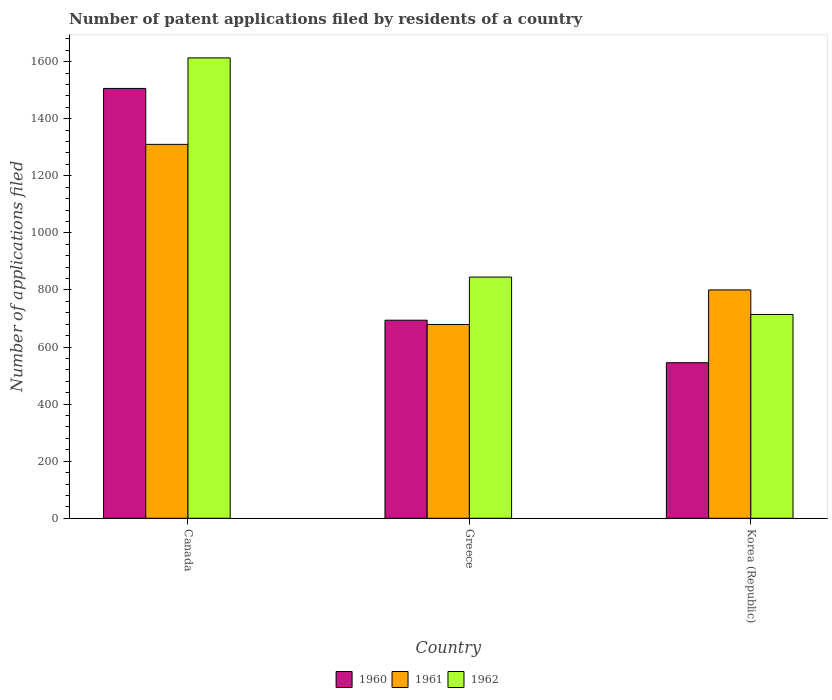How many different coloured bars are there?
Give a very brief answer. 3. How many groups of bars are there?
Offer a very short reply. 3. How many bars are there on the 1st tick from the left?
Offer a terse response. 3. What is the label of the 3rd group of bars from the left?
Your response must be concise. Korea (Republic). What is the number of applications filed in 1960 in Korea (Republic)?
Your response must be concise. 545. Across all countries, what is the maximum number of applications filed in 1961?
Ensure brevity in your answer.  1310. Across all countries, what is the minimum number of applications filed in 1960?
Your response must be concise. 545. What is the total number of applications filed in 1961 in the graph?
Ensure brevity in your answer.  2789. What is the difference between the number of applications filed in 1961 in Canada and that in Greece?
Provide a short and direct response. 631. What is the difference between the number of applications filed in 1962 in Canada and the number of applications filed in 1961 in Korea (Republic)?
Offer a terse response. 813. What is the average number of applications filed in 1962 per country?
Your response must be concise. 1057.33. What is the difference between the number of applications filed of/in 1962 and number of applications filed of/in 1961 in Greece?
Your answer should be compact. 166. In how many countries, is the number of applications filed in 1962 greater than 440?
Offer a very short reply. 3. What is the ratio of the number of applications filed in 1961 in Canada to that in Greece?
Ensure brevity in your answer.  1.93. Is the number of applications filed in 1962 in Greece less than that in Korea (Republic)?
Keep it short and to the point. No. What is the difference between the highest and the second highest number of applications filed in 1960?
Your answer should be compact. -961. What is the difference between the highest and the lowest number of applications filed in 1960?
Your answer should be very brief. 961. What does the 1st bar from the left in Canada represents?
Offer a very short reply. 1960. What does the 3rd bar from the right in Korea (Republic) represents?
Provide a short and direct response. 1960. Is it the case that in every country, the sum of the number of applications filed in 1962 and number of applications filed in 1961 is greater than the number of applications filed in 1960?
Your answer should be compact. Yes. Are the values on the major ticks of Y-axis written in scientific E-notation?
Your answer should be compact. No. Does the graph contain any zero values?
Make the answer very short. No. Does the graph contain grids?
Keep it short and to the point. No. How many legend labels are there?
Offer a terse response. 3. How are the legend labels stacked?
Offer a terse response. Horizontal. What is the title of the graph?
Provide a short and direct response. Number of patent applications filed by residents of a country. Does "2010" appear as one of the legend labels in the graph?
Provide a short and direct response. No. What is the label or title of the Y-axis?
Your answer should be compact. Number of applications filed. What is the Number of applications filed in 1960 in Canada?
Offer a terse response. 1506. What is the Number of applications filed of 1961 in Canada?
Your answer should be compact. 1310. What is the Number of applications filed of 1962 in Canada?
Your answer should be compact. 1613. What is the Number of applications filed of 1960 in Greece?
Ensure brevity in your answer.  694. What is the Number of applications filed in 1961 in Greece?
Provide a short and direct response. 679. What is the Number of applications filed of 1962 in Greece?
Offer a very short reply. 845. What is the Number of applications filed in 1960 in Korea (Republic)?
Provide a succinct answer. 545. What is the Number of applications filed in 1961 in Korea (Republic)?
Keep it short and to the point. 800. What is the Number of applications filed of 1962 in Korea (Republic)?
Provide a succinct answer. 714. Across all countries, what is the maximum Number of applications filed of 1960?
Give a very brief answer. 1506. Across all countries, what is the maximum Number of applications filed of 1961?
Make the answer very short. 1310. Across all countries, what is the maximum Number of applications filed in 1962?
Provide a short and direct response. 1613. Across all countries, what is the minimum Number of applications filed of 1960?
Your response must be concise. 545. Across all countries, what is the minimum Number of applications filed in 1961?
Offer a very short reply. 679. Across all countries, what is the minimum Number of applications filed of 1962?
Give a very brief answer. 714. What is the total Number of applications filed in 1960 in the graph?
Your answer should be compact. 2745. What is the total Number of applications filed in 1961 in the graph?
Ensure brevity in your answer.  2789. What is the total Number of applications filed in 1962 in the graph?
Offer a terse response. 3172. What is the difference between the Number of applications filed in 1960 in Canada and that in Greece?
Your response must be concise. 812. What is the difference between the Number of applications filed in 1961 in Canada and that in Greece?
Your answer should be very brief. 631. What is the difference between the Number of applications filed of 1962 in Canada and that in Greece?
Your response must be concise. 768. What is the difference between the Number of applications filed of 1960 in Canada and that in Korea (Republic)?
Give a very brief answer. 961. What is the difference between the Number of applications filed in 1961 in Canada and that in Korea (Republic)?
Your response must be concise. 510. What is the difference between the Number of applications filed in 1962 in Canada and that in Korea (Republic)?
Your answer should be compact. 899. What is the difference between the Number of applications filed of 1960 in Greece and that in Korea (Republic)?
Keep it short and to the point. 149. What is the difference between the Number of applications filed in 1961 in Greece and that in Korea (Republic)?
Keep it short and to the point. -121. What is the difference between the Number of applications filed in 1962 in Greece and that in Korea (Republic)?
Your answer should be compact. 131. What is the difference between the Number of applications filed in 1960 in Canada and the Number of applications filed in 1961 in Greece?
Provide a short and direct response. 827. What is the difference between the Number of applications filed of 1960 in Canada and the Number of applications filed of 1962 in Greece?
Provide a short and direct response. 661. What is the difference between the Number of applications filed in 1961 in Canada and the Number of applications filed in 1962 in Greece?
Offer a terse response. 465. What is the difference between the Number of applications filed of 1960 in Canada and the Number of applications filed of 1961 in Korea (Republic)?
Keep it short and to the point. 706. What is the difference between the Number of applications filed of 1960 in Canada and the Number of applications filed of 1962 in Korea (Republic)?
Provide a succinct answer. 792. What is the difference between the Number of applications filed of 1961 in Canada and the Number of applications filed of 1962 in Korea (Republic)?
Your response must be concise. 596. What is the difference between the Number of applications filed of 1960 in Greece and the Number of applications filed of 1961 in Korea (Republic)?
Your answer should be very brief. -106. What is the difference between the Number of applications filed in 1960 in Greece and the Number of applications filed in 1962 in Korea (Republic)?
Keep it short and to the point. -20. What is the difference between the Number of applications filed in 1961 in Greece and the Number of applications filed in 1962 in Korea (Republic)?
Make the answer very short. -35. What is the average Number of applications filed of 1960 per country?
Offer a terse response. 915. What is the average Number of applications filed in 1961 per country?
Your answer should be compact. 929.67. What is the average Number of applications filed in 1962 per country?
Keep it short and to the point. 1057.33. What is the difference between the Number of applications filed in 1960 and Number of applications filed in 1961 in Canada?
Ensure brevity in your answer.  196. What is the difference between the Number of applications filed of 1960 and Number of applications filed of 1962 in Canada?
Offer a very short reply. -107. What is the difference between the Number of applications filed of 1961 and Number of applications filed of 1962 in Canada?
Give a very brief answer. -303. What is the difference between the Number of applications filed in 1960 and Number of applications filed in 1962 in Greece?
Ensure brevity in your answer.  -151. What is the difference between the Number of applications filed in 1961 and Number of applications filed in 1962 in Greece?
Ensure brevity in your answer.  -166. What is the difference between the Number of applications filed in 1960 and Number of applications filed in 1961 in Korea (Republic)?
Ensure brevity in your answer.  -255. What is the difference between the Number of applications filed in 1960 and Number of applications filed in 1962 in Korea (Republic)?
Your answer should be compact. -169. What is the ratio of the Number of applications filed of 1960 in Canada to that in Greece?
Provide a short and direct response. 2.17. What is the ratio of the Number of applications filed in 1961 in Canada to that in Greece?
Provide a short and direct response. 1.93. What is the ratio of the Number of applications filed of 1962 in Canada to that in Greece?
Your answer should be very brief. 1.91. What is the ratio of the Number of applications filed in 1960 in Canada to that in Korea (Republic)?
Your answer should be very brief. 2.76. What is the ratio of the Number of applications filed in 1961 in Canada to that in Korea (Republic)?
Keep it short and to the point. 1.64. What is the ratio of the Number of applications filed in 1962 in Canada to that in Korea (Republic)?
Keep it short and to the point. 2.26. What is the ratio of the Number of applications filed of 1960 in Greece to that in Korea (Republic)?
Offer a very short reply. 1.27. What is the ratio of the Number of applications filed in 1961 in Greece to that in Korea (Republic)?
Provide a short and direct response. 0.85. What is the ratio of the Number of applications filed of 1962 in Greece to that in Korea (Republic)?
Your answer should be compact. 1.18. What is the difference between the highest and the second highest Number of applications filed in 1960?
Keep it short and to the point. 812. What is the difference between the highest and the second highest Number of applications filed in 1961?
Offer a very short reply. 510. What is the difference between the highest and the second highest Number of applications filed of 1962?
Make the answer very short. 768. What is the difference between the highest and the lowest Number of applications filed of 1960?
Offer a terse response. 961. What is the difference between the highest and the lowest Number of applications filed in 1961?
Make the answer very short. 631. What is the difference between the highest and the lowest Number of applications filed in 1962?
Provide a short and direct response. 899. 